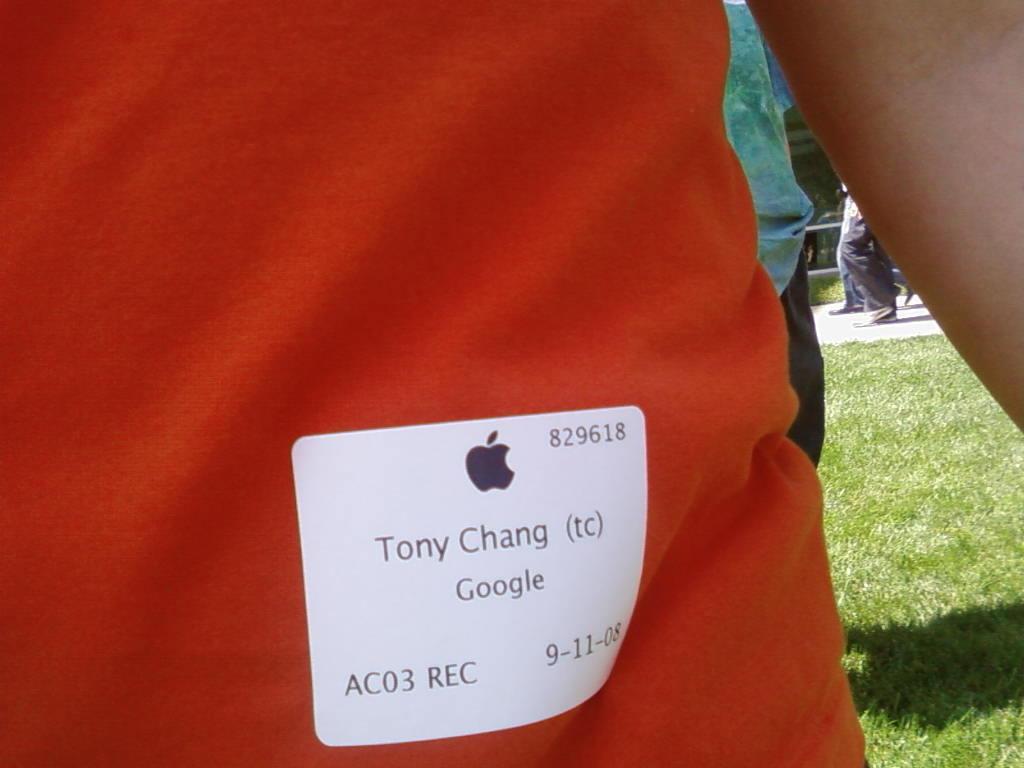Describe this image in one or two sentences. In this image I see the orange color cloth on which there is a white paper and I see numbers and words written on it and I see a logo over here. In the background I see few persons and I see the green grass. 